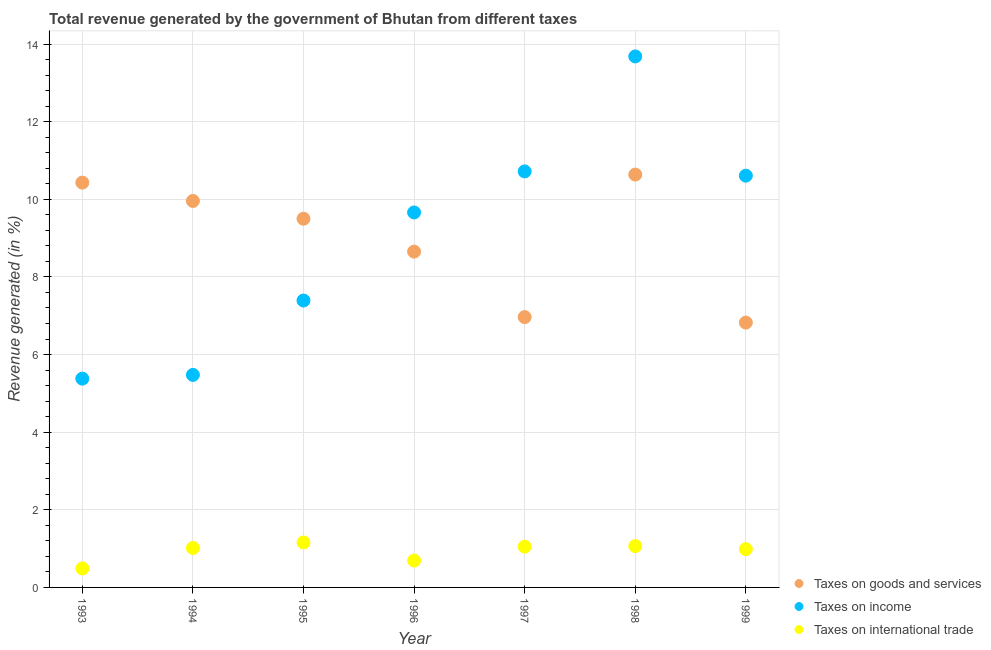What is the percentage of revenue generated by taxes on goods and services in 1999?
Your response must be concise. 6.82. Across all years, what is the maximum percentage of revenue generated by tax on international trade?
Your answer should be very brief. 1.16. Across all years, what is the minimum percentage of revenue generated by tax on international trade?
Offer a very short reply. 0.49. What is the total percentage of revenue generated by taxes on goods and services in the graph?
Provide a succinct answer. 62.97. What is the difference between the percentage of revenue generated by tax on international trade in 1996 and that in 1998?
Keep it short and to the point. -0.37. What is the difference between the percentage of revenue generated by taxes on income in 1998 and the percentage of revenue generated by taxes on goods and services in 1996?
Your answer should be compact. 5.03. What is the average percentage of revenue generated by taxes on income per year?
Your answer should be very brief. 8.99. In the year 1994, what is the difference between the percentage of revenue generated by tax on international trade and percentage of revenue generated by taxes on goods and services?
Offer a very short reply. -8.94. What is the ratio of the percentage of revenue generated by taxes on income in 1994 to that in 1996?
Your answer should be compact. 0.57. Is the percentage of revenue generated by taxes on goods and services in 1995 less than that in 1998?
Give a very brief answer. Yes. What is the difference between the highest and the second highest percentage of revenue generated by taxes on income?
Keep it short and to the point. 2.96. What is the difference between the highest and the lowest percentage of revenue generated by tax on international trade?
Ensure brevity in your answer.  0.67. In how many years, is the percentage of revenue generated by tax on international trade greater than the average percentage of revenue generated by tax on international trade taken over all years?
Make the answer very short. 5. Is the sum of the percentage of revenue generated by taxes on income in 1995 and 1998 greater than the maximum percentage of revenue generated by taxes on goods and services across all years?
Provide a succinct answer. Yes. Is it the case that in every year, the sum of the percentage of revenue generated by taxes on goods and services and percentage of revenue generated by taxes on income is greater than the percentage of revenue generated by tax on international trade?
Offer a very short reply. Yes. Does the percentage of revenue generated by tax on international trade monotonically increase over the years?
Give a very brief answer. No. Does the graph contain any zero values?
Make the answer very short. No. How many legend labels are there?
Offer a terse response. 3. What is the title of the graph?
Offer a very short reply. Total revenue generated by the government of Bhutan from different taxes. What is the label or title of the Y-axis?
Keep it short and to the point. Revenue generated (in %). What is the Revenue generated (in %) in Taxes on goods and services in 1993?
Offer a very short reply. 10.43. What is the Revenue generated (in %) of Taxes on income in 1993?
Give a very brief answer. 5.38. What is the Revenue generated (in %) of Taxes on international trade in 1993?
Provide a short and direct response. 0.49. What is the Revenue generated (in %) in Taxes on goods and services in 1994?
Make the answer very short. 9.96. What is the Revenue generated (in %) of Taxes on income in 1994?
Your answer should be compact. 5.48. What is the Revenue generated (in %) of Taxes on international trade in 1994?
Offer a terse response. 1.02. What is the Revenue generated (in %) in Taxes on goods and services in 1995?
Your answer should be compact. 9.5. What is the Revenue generated (in %) in Taxes on income in 1995?
Your answer should be compact. 7.39. What is the Revenue generated (in %) of Taxes on international trade in 1995?
Your answer should be very brief. 1.16. What is the Revenue generated (in %) of Taxes on goods and services in 1996?
Ensure brevity in your answer.  8.65. What is the Revenue generated (in %) in Taxes on income in 1996?
Provide a short and direct response. 9.66. What is the Revenue generated (in %) of Taxes on international trade in 1996?
Offer a very short reply. 0.69. What is the Revenue generated (in %) of Taxes on goods and services in 1997?
Provide a succinct answer. 6.97. What is the Revenue generated (in %) in Taxes on income in 1997?
Provide a short and direct response. 10.72. What is the Revenue generated (in %) of Taxes on international trade in 1997?
Ensure brevity in your answer.  1.05. What is the Revenue generated (in %) of Taxes on goods and services in 1998?
Provide a succinct answer. 10.64. What is the Revenue generated (in %) of Taxes on income in 1998?
Offer a very short reply. 13.68. What is the Revenue generated (in %) in Taxes on international trade in 1998?
Provide a succinct answer. 1.07. What is the Revenue generated (in %) in Taxes on goods and services in 1999?
Offer a very short reply. 6.82. What is the Revenue generated (in %) in Taxes on income in 1999?
Offer a very short reply. 10.61. What is the Revenue generated (in %) of Taxes on international trade in 1999?
Make the answer very short. 0.99. Across all years, what is the maximum Revenue generated (in %) in Taxes on goods and services?
Keep it short and to the point. 10.64. Across all years, what is the maximum Revenue generated (in %) in Taxes on income?
Provide a succinct answer. 13.68. Across all years, what is the maximum Revenue generated (in %) of Taxes on international trade?
Offer a terse response. 1.16. Across all years, what is the minimum Revenue generated (in %) of Taxes on goods and services?
Your answer should be compact. 6.82. Across all years, what is the minimum Revenue generated (in %) in Taxes on income?
Your answer should be compact. 5.38. Across all years, what is the minimum Revenue generated (in %) in Taxes on international trade?
Offer a terse response. 0.49. What is the total Revenue generated (in %) in Taxes on goods and services in the graph?
Your response must be concise. 62.97. What is the total Revenue generated (in %) in Taxes on income in the graph?
Your response must be concise. 62.92. What is the total Revenue generated (in %) of Taxes on international trade in the graph?
Your answer should be compact. 6.46. What is the difference between the Revenue generated (in %) in Taxes on goods and services in 1993 and that in 1994?
Provide a succinct answer. 0.47. What is the difference between the Revenue generated (in %) of Taxes on income in 1993 and that in 1994?
Offer a very short reply. -0.1. What is the difference between the Revenue generated (in %) of Taxes on international trade in 1993 and that in 1994?
Keep it short and to the point. -0.53. What is the difference between the Revenue generated (in %) of Taxes on goods and services in 1993 and that in 1995?
Give a very brief answer. 0.93. What is the difference between the Revenue generated (in %) of Taxes on income in 1993 and that in 1995?
Your answer should be very brief. -2.01. What is the difference between the Revenue generated (in %) of Taxes on international trade in 1993 and that in 1995?
Give a very brief answer. -0.67. What is the difference between the Revenue generated (in %) of Taxes on goods and services in 1993 and that in 1996?
Offer a very short reply. 1.78. What is the difference between the Revenue generated (in %) in Taxes on income in 1993 and that in 1996?
Your answer should be very brief. -4.28. What is the difference between the Revenue generated (in %) of Taxes on international trade in 1993 and that in 1996?
Give a very brief answer. -0.2. What is the difference between the Revenue generated (in %) of Taxes on goods and services in 1993 and that in 1997?
Give a very brief answer. 3.47. What is the difference between the Revenue generated (in %) in Taxes on income in 1993 and that in 1997?
Your response must be concise. -5.34. What is the difference between the Revenue generated (in %) in Taxes on international trade in 1993 and that in 1997?
Your response must be concise. -0.56. What is the difference between the Revenue generated (in %) in Taxes on goods and services in 1993 and that in 1998?
Your answer should be compact. -0.21. What is the difference between the Revenue generated (in %) in Taxes on income in 1993 and that in 1998?
Offer a very short reply. -8.3. What is the difference between the Revenue generated (in %) of Taxes on international trade in 1993 and that in 1998?
Offer a terse response. -0.58. What is the difference between the Revenue generated (in %) of Taxes on goods and services in 1993 and that in 1999?
Your answer should be very brief. 3.61. What is the difference between the Revenue generated (in %) of Taxes on income in 1993 and that in 1999?
Your answer should be very brief. -5.23. What is the difference between the Revenue generated (in %) of Taxes on international trade in 1993 and that in 1999?
Offer a very short reply. -0.5. What is the difference between the Revenue generated (in %) of Taxes on goods and services in 1994 and that in 1995?
Give a very brief answer. 0.46. What is the difference between the Revenue generated (in %) of Taxes on income in 1994 and that in 1995?
Your answer should be very brief. -1.92. What is the difference between the Revenue generated (in %) in Taxes on international trade in 1994 and that in 1995?
Offer a very short reply. -0.14. What is the difference between the Revenue generated (in %) in Taxes on goods and services in 1994 and that in 1996?
Provide a succinct answer. 1.31. What is the difference between the Revenue generated (in %) in Taxes on income in 1994 and that in 1996?
Offer a very short reply. -4.19. What is the difference between the Revenue generated (in %) of Taxes on international trade in 1994 and that in 1996?
Keep it short and to the point. 0.33. What is the difference between the Revenue generated (in %) in Taxes on goods and services in 1994 and that in 1997?
Keep it short and to the point. 2.99. What is the difference between the Revenue generated (in %) in Taxes on income in 1994 and that in 1997?
Provide a succinct answer. -5.24. What is the difference between the Revenue generated (in %) in Taxes on international trade in 1994 and that in 1997?
Your answer should be very brief. -0.03. What is the difference between the Revenue generated (in %) in Taxes on goods and services in 1994 and that in 1998?
Provide a succinct answer. -0.68. What is the difference between the Revenue generated (in %) in Taxes on income in 1994 and that in 1998?
Provide a short and direct response. -8.21. What is the difference between the Revenue generated (in %) in Taxes on international trade in 1994 and that in 1998?
Keep it short and to the point. -0.05. What is the difference between the Revenue generated (in %) in Taxes on goods and services in 1994 and that in 1999?
Your answer should be compact. 3.13. What is the difference between the Revenue generated (in %) in Taxes on income in 1994 and that in 1999?
Give a very brief answer. -5.13. What is the difference between the Revenue generated (in %) of Taxes on international trade in 1994 and that in 1999?
Your answer should be very brief. 0.03. What is the difference between the Revenue generated (in %) in Taxes on goods and services in 1995 and that in 1996?
Ensure brevity in your answer.  0.85. What is the difference between the Revenue generated (in %) in Taxes on income in 1995 and that in 1996?
Provide a succinct answer. -2.27. What is the difference between the Revenue generated (in %) in Taxes on international trade in 1995 and that in 1996?
Your response must be concise. 0.47. What is the difference between the Revenue generated (in %) in Taxes on goods and services in 1995 and that in 1997?
Ensure brevity in your answer.  2.53. What is the difference between the Revenue generated (in %) in Taxes on income in 1995 and that in 1997?
Give a very brief answer. -3.33. What is the difference between the Revenue generated (in %) in Taxes on international trade in 1995 and that in 1997?
Your answer should be compact. 0.11. What is the difference between the Revenue generated (in %) of Taxes on goods and services in 1995 and that in 1998?
Offer a very short reply. -1.14. What is the difference between the Revenue generated (in %) of Taxes on income in 1995 and that in 1998?
Your answer should be compact. -6.29. What is the difference between the Revenue generated (in %) in Taxes on international trade in 1995 and that in 1998?
Keep it short and to the point. 0.09. What is the difference between the Revenue generated (in %) of Taxes on goods and services in 1995 and that in 1999?
Your answer should be compact. 2.68. What is the difference between the Revenue generated (in %) in Taxes on income in 1995 and that in 1999?
Your answer should be compact. -3.22. What is the difference between the Revenue generated (in %) of Taxes on international trade in 1995 and that in 1999?
Provide a succinct answer. 0.17. What is the difference between the Revenue generated (in %) of Taxes on goods and services in 1996 and that in 1997?
Provide a short and direct response. 1.69. What is the difference between the Revenue generated (in %) in Taxes on income in 1996 and that in 1997?
Your answer should be very brief. -1.06. What is the difference between the Revenue generated (in %) in Taxes on international trade in 1996 and that in 1997?
Make the answer very short. -0.36. What is the difference between the Revenue generated (in %) of Taxes on goods and services in 1996 and that in 1998?
Offer a very short reply. -1.99. What is the difference between the Revenue generated (in %) of Taxes on income in 1996 and that in 1998?
Provide a short and direct response. -4.02. What is the difference between the Revenue generated (in %) in Taxes on international trade in 1996 and that in 1998?
Give a very brief answer. -0.37. What is the difference between the Revenue generated (in %) in Taxes on goods and services in 1996 and that in 1999?
Your answer should be very brief. 1.83. What is the difference between the Revenue generated (in %) in Taxes on income in 1996 and that in 1999?
Provide a succinct answer. -0.95. What is the difference between the Revenue generated (in %) in Taxes on international trade in 1996 and that in 1999?
Your answer should be very brief. -0.29. What is the difference between the Revenue generated (in %) in Taxes on goods and services in 1997 and that in 1998?
Offer a very short reply. -3.67. What is the difference between the Revenue generated (in %) in Taxes on income in 1997 and that in 1998?
Provide a short and direct response. -2.96. What is the difference between the Revenue generated (in %) of Taxes on international trade in 1997 and that in 1998?
Keep it short and to the point. -0.02. What is the difference between the Revenue generated (in %) in Taxes on goods and services in 1997 and that in 1999?
Provide a short and direct response. 0.14. What is the difference between the Revenue generated (in %) in Taxes on income in 1997 and that in 1999?
Make the answer very short. 0.11. What is the difference between the Revenue generated (in %) in Taxes on international trade in 1997 and that in 1999?
Offer a terse response. 0.06. What is the difference between the Revenue generated (in %) of Taxes on goods and services in 1998 and that in 1999?
Offer a terse response. 3.81. What is the difference between the Revenue generated (in %) of Taxes on income in 1998 and that in 1999?
Provide a short and direct response. 3.07. What is the difference between the Revenue generated (in %) in Taxes on international trade in 1998 and that in 1999?
Ensure brevity in your answer.  0.08. What is the difference between the Revenue generated (in %) of Taxes on goods and services in 1993 and the Revenue generated (in %) of Taxes on income in 1994?
Provide a short and direct response. 4.96. What is the difference between the Revenue generated (in %) in Taxes on goods and services in 1993 and the Revenue generated (in %) in Taxes on international trade in 1994?
Make the answer very short. 9.41. What is the difference between the Revenue generated (in %) of Taxes on income in 1993 and the Revenue generated (in %) of Taxes on international trade in 1994?
Provide a short and direct response. 4.36. What is the difference between the Revenue generated (in %) in Taxes on goods and services in 1993 and the Revenue generated (in %) in Taxes on income in 1995?
Ensure brevity in your answer.  3.04. What is the difference between the Revenue generated (in %) in Taxes on goods and services in 1993 and the Revenue generated (in %) in Taxes on international trade in 1995?
Give a very brief answer. 9.27. What is the difference between the Revenue generated (in %) of Taxes on income in 1993 and the Revenue generated (in %) of Taxes on international trade in 1995?
Your answer should be very brief. 4.22. What is the difference between the Revenue generated (in %) in Taxes on goods and services in 1993 and the Revenue generated (in %) in Taxes on income in 1996?
Ensure brevity in your answer.  0.77. What is the difference between the Revenue generated (in %) in Taxes on goods and services in 1993 and the Revenue generated (in %) in Taxes on international trade in 1996?
Your answer should be very brief. 9.74. What is the difference between the Revenue generated (in %) of Taxes on income in 1993 and the Revenue generated (in %) of Taxes on international trade in 1996?
Make the answer very short. 4.69. What is the difference between the Revenue generated (in %) of Taxes on goods and services in 1993 and the Revenue generated (in %) of Taxes on income in 1997?
Offer a terse response. -0.29. What is the difference between the Revenue generated (in %) in Taxes on goods and services in 1993 and the Revenue generated (in %) in Taxes on international trade in 1997?
Your response must be concise. 9.38. What is the difference between the Revenue generated (in %) of Taxes on income in 1993 and the Revenue generated (in %) of Taxes on international trade in 1997?
Your response must be concise. 4.33. What is the difference between the Revenue generated (in %) of Taxes on goods and services in 1993 and the Revenue generated (in %) of Taxes on income in 1998?
Ensure brevity in your answer.  -3.25. What is the difference between the Revenue generated (in %) in Taxes on goods and services in 1993 and the Revenue generated (in %) in Taxes on international trade in 1998?
Your answer should be compact. 9.37. What is the difference between the Revenue generated (in %) in Taxes on income in 1993 and the Revenue generated (in %) in Taxes on international trade in 1998?
Ensure brevity in your answer.  4.31. What is the difference between the Revenue generated (in %) in Taxes on goods and services in 1993 and the Revenue generated (in %) in Taxes on income in 1999?
Provide a short and direct response. -0.18. What is the difference between the Revenue generated (in %) of Taxes on goods and services in 1993 and the Revenue generated (in %) of Taxes on international trade in 1999?
Keep it short and to the point. 9.44. What is the difference between the Revenue generated (in %) of Taxes on income in 1993 and the Revenue generated (in %) of Taxes on international trade in 1999?
Your answer should be very brief. 4.39. What is the difference between the Revenue generated (in %) of Taxes on goods and services in 1994 and the Revenue generated (in %) of Taxes on income in 1995?
Ensure brevity in your answer.  2.57. What is the difference between the Revenue generated (in %) in Taxes on goods and services in 1994 and the Revenue generated (in %) in Taxes on international trade in 1995?
Offer a very short reply. 8.8. What is the difference between the Revenue generated (in %) in Taxes on income in 1994 and the Revenue generated (in %) in Taxes on international trade in 1995?
Ensure brevity in your answer.  4.32. What is the difference between the Revenue generated (in %) of Taxes on goods and services in 1994 and the Revenue generated (in %) of Taxes on income in 1996?
Provide a short and direct response. 0.3. What is the difference between the Revenue generated (in %) in Taxes on goods and services in 1994 and the Revenue generated (in %) in Taxes on international trade in 1996?
Offer a very short reply. 9.27. What is the difference between the Revenue generated (in %) in Taxes on income in 1994 and the Revenue generated (in %) in Taxes on international trade in 1996?
Offer a very short reply. 4.78. What is the difference between the Revenue generated (in %) of Taxes on goods and services in 1994 and the Revenue generated (in %) of Taxes on income in 1997?
Make the answer very short. -0.76. What is the difference between the Revenue generated (in %) of Taxes on goods and services in 1994 and the Revenue generated (in %) of Taxes on international trade in 1997?
Your answer should be very brief. 8.91. What is the difference between the Revenue generated (in %) in Taxes on income in 1994 and the Revenue generated (in %) in Taxes on international trade in 1997?
Offer a very short reply. 4.43. What is the difference between the Revenue generated (in %) of Taxes on goods and services in 1994 and the Revenue generated (in %) of Taxes on income in 1998?
Give a very brief answer. -3.72. What is the difference between the Revenue generated (in %) in Taxes on goods and services in 1994 and the Revenue generated (in %) in Taxes on international trade in 1998?
Offer a very short reply. 8.89. What is the difference between the Revenue generated (in %) of Taxes on income in 1994 and the Revenue generated (in %) of Taxes on international trade in 1998?
Offer a terse response. 4.41. What is the difference between the Revenue generated (in %) of Taxes on goods and services in 1994 and the Revenue generated (in %) of Taxes on income in 1999?
Your answer should be compact. -0.65. What is the difference between the Revenue generated (in %) in Taxes on goods and services in 1994 and the Revenue generated (in %) in Taxes on international trade in 1999?
Your answer should be compact. 8.97. What is the difference between the Revenue generated (in %) of Taxes on income in 1994 and the Revenue generated (in %) of Taxes on international trade in 1999?
Make the answer very short. 4.49. What is the difference between the Revenue generated (in %) of Taxes on goods and services in 1995 and the Revenue generated (in %) of Taxes on income in 1996?
Your response must be concise. -0.16. What is the difference between the Revenue generated (in %) of Taxes on goods and services in 1995 and the Revenue generated (in %) of Taxes on international trade in 1996?
Offer a terse response. 8.81. What is the difference between the Revenue generated (in %) in Taxes on income in 1995 and the Revenue generated (in %) in Taxes on international trade in 1996?
Offer a terse response. 6.7. What is the difference between the Revenue generated (in %) of Taxes on goods and services in 1995 and the Revenue generated (in %) of Taxes on income in 1997?
Your answer should be compact. -1.22. What is the difference between the Revenue generated (in %) in Taxes on goods and services in 1995 and the Revenue generated (in %) in Taxes on international trade in 1997?
Provide a short and direct response. 8.45. What is the difference between the Revenue generated (in %) in Taxes on income in 1995 and the Revenue generated (in %) in Taxes on international trade in 1997?
Your answer should be compact. 6.34. What is the difference between the Revenue generated (in %) of Taxes on goods and services in 1995 and the Revenue generated (in %) of Taxes on income in 1998?
Offer a very short reply. -4.18. What is the difference between the Revenue generated (in %) of Taxes on goods and services in 1995 and the Revenue generated (in %) of Taxes on international trade in 1998?
Your answer should be very brief. 8.43. What is the difference between the Revenue generated (in %) of Taxes on income in 1995 and the Revenue generated (in %) of Taxes on international trade in 1998?
Make the answer very short. 6.33. What is the difference between the Revenue generated (in %) in Taxes on goods and services in 1995 and the Revenue generated (in %) in Taxes on income in 1999?
Your response must be concise. -1.11. What is the difference between the Revenue generated (in %) in Taxes on goods and services in 1995 and the Revenue generated (in %) in Taxes on international trade in 1999?
Your response must be concise. 8.51. What is the difference between the Revenue generated (in %) in Taxes on income in 1995 and the Revenue generated (in %) in Taxes on international trade in 1999?
Provide a short and direct response. 6.41. What is the difference between the Revenue generated (in %) of Taxes on goods and services in 1996 and the Revenue generated (in %) of Taxes on income in 1997?
Your answer should be very brief. -2.07. What is the difference between the Revenue generated (in %) in Taxes on goods and services in 1996 and the Revenue generated (in %) in Taxes on international trade in 1997?
Offer a very short reply. 7.6. What is the difference between the Revenue generated (in %) of Taxes on income in 1996 and the Revenue generated (in %) of Taxes on international trade in 1997?
Provide a succinct answer. 8.61. What is the difference between the Revenue generated (in %) in Taxes on goods and services in 1996 and the Revenue generated (in %) in Taxes on income in 1998?
Give a very brief answer. -5.03. What is the difference between the Revenue generated (in %) in Taxes on goods and services in 1996 and the Revenue generated (in %) in Taxes on international trade in 1998?
Provide a succinct answer. 7.59. What is the difference between the Revenue generated (in %) in Taxes on income in 1996 and the Revenue generated (in %) in Taxes on international trade in 1998?
Your answer should be compact. 8.6. What is the difference between the Revenue generated (in %) in Taxes on goods and services in 1996 and the Revenue generated (in %) in Taxes on income in 1999?
Provide a short and direct response. -1.96. What is the difference between the Revenue generated (in %) in Taxes on goods and services in 1996 and the Revenue generated (in %) in Taxes on international trade in 1999?
Your response must be concise. 7.67. What is the difference between the Revenue generated (in %) of Taxes on income in 1996 and the Revenue generated (in %) of Taxes on international trade in 1999?
Offer a very short reply. 8.68. What is the difference between the Revenue generated (in %) of Taxes on goods and services in 1997 and the Revenue generated (in %) of Taxes on income in 1998?
Provide a short and direct response. -6.72. What is the difference between the Revenue generated (in %) in Taxes on goods and services in 1997 and the Revenue generated (in %) in Taxes on international trade in 1998?
Offer a terse response. 5.9. What is the difference between the Revenue generated (in %) in Taxes on income in 1997 and the Revenue generated (in %) in Taxes on international trade in 1998?
Ensure brevity in your answer.  9.65. What is the difference between the Revenue generated (in %) of Taxes on goods and services in 1997 and the Revenue generated (in %) of Taxes on income in 1999?
Give a very brief answer. -3.64. What is the difference between the Revenue generated (in %) of Taxes on goods and services in 1997 and the Revenue generated (in %) of Taxes on international trade in 1999?
Your response must be concise. 5.98. What is the difference between the Revenue generated (in %) in Taxes on income in 1997 and the Revenue generated (in %) in Taxes on international trade in 1999?
Your answer should be compact. 9.73. What is the difference between the Revenue generated (in %) in Taxes on goods and services in 1998 and the Revenue generated (in %) in Taxes on income in 1999?
Ensure brevity in your answer.  0.03. What is the difference between the Revenue generated (in %) of Taxes on goods and services in 1998 and the Revenue generated (in %) of Taxes on international trade in 1999?
Your answer should be very brief. 9.65. What is the difference between the Revenue generated (in %) in Taxes on income in 1998 and the Revenue generated (in %) in Taxes on international trade in 1999?
Your response must be concise. 12.7. What is the average Revenue generated (in %) in Taxes on goods and services per year?
Provide a succinct answer. 9. What is the average Revenue generated (in %) of Taxes on income per year?
Your response must be concise. 8.99. What is the average Revenue generated (in %) in Taxes on international trade per year?
Provide a short and direct response. 0.92. In the year 1993, what is the difference between the Revenue generated (in %) in Taxes on goods and services and Revenue generated (in %) in Taxes on income?
Provide a short and direct response. 5.05. In the year 1993, what is the difference between the Revenue generated (in %) of Taxes on goods and services and Revenue generated (in %) of Taxes on international trade?
Provide a short and direct response. 9.94. In the year 1993, what is the difference between the Revenue generated (in %) in Taxes on income and Revenue generated (in %) in Taxes on international trade?
Offer a terse response. 4.89. In the year 1994, what is the difference between the Revenue generated (in %) of Taxes on goods and services and Revenue generated (in %) of Taxes on income?
Provide a succinct answer. 4.48. In the year 1994, what is the difference between the Revenue generated (in %) of Taxes on goods and services and Revenue generated (in %) of Taxes on international trade?
Give a very brief answer. 8.94. In the year 1994, what is the difference between the Revenue generated (in %) in Taxes on income and Revenue generated (in %) in Taxes on international trade?
Your response must be concise. 4.46. In the year 1995, what is the difference between the Revenue generated (in %) in Taxes on goods and services and Revenue generated (in %) in Taxes on income?
Give a very brief answer. 2.11. In the year 1995, what is the difference between the Revenue generated (in %) of Taxes on goods and services and Revenue generated (in %) of Taxes on international trade?
Ensure brevity in your answer.  8.34. In the year 1995, what is the difference between the Revenue generated (in %) in Taxes on income and Revenue generated (in %) in Taxes on international trade?
Keep it short and to the point. 6.23. In the year 1996, what is the difference between the Revenue generated (in %) in Taxes on goods and services and Revenue generated (in %) in Taxes on income?
Your response must be concise. -1.01. In the year 1996, what is the difference between the Revenue generated (in %) of Taxes on goods and services and Revenue generated (in %) of Taxes on international trade?
Offer a very short reply. 7.96. In the year 1996, what is the difference between the Revenue generated (in %) in Taxes on income and Revenue generated (in %) in Taxes on international trade?
Provide a succinct answer. 8.97. In the year 1997, what is the difference between the Revenue generated (in %) of Taxes on goods and services and Revenue generated (in %) of Taxes on income?
Keep it short and to the point. -3.75. In the year 1997, what is the difference between the Revenue generated (in %) of Taxes on goods and services and Revenue generated (in %) of Taxes on international trade?
Keep it short and to the point. 5.92. In the year 1997, what is the difference between the Revenue generated (in %) of Taxes on income and Revenue generated (in %) of Taxes on international trade?
Your response must be concise. 9.67. In the year 1998, what is the difference between the Revenue generated (in %) of Taxes on goods and services and Revenue generated (in %) of Taxes on income?
Keep it short and to the point. -3.04. In the year 1998, what is the difference between the Revenue generated (in %) in Taxes on goods and services and Revenue generated (in %) in Taxes on international trade?
Make the answer very short. 9.57. In the year 1998, what is the difference between the Revenue generated (in %) in Taxes on income and Revenue generated (in %) in Taxes on international trade?
Give a very brief answer. 12.62. In the year 1999, what is the difference between the Revenue generated (in %) in Taxes on goods and services and Revenue generated (in %) in Taxes on income?
Your response must be concise. -3.79. In the year 1999, what is the difference between the Revenue generated (in %) of Taxes on goods and services and Revenue generated (in %) of Taxes on international trade?
Ensure brevity in your answer.  5.84. In the year 1999, what is the difference between the Revenue generated (in %) of Taxes on income and Revenue generated (in %) of Taxes on international trade?
Ensure brevity in your answer.  9.62. What is the ratio of the Revenue generated (in %) of Taxes on goods and services in 1993 to that in 1994?
Your answer should be very brief. 1.05. What is the ratio of the Revenue generated (in %) of Taxes on income in 1993 to that in 1994?
Your answer should be compact. 0.98. What is the ratio of the Revenue generated (in %) of Taxes on international trade in 1993 to that in 1994?
Give a very brief answer. 0.48. What is the ratio of the Revenue generated (in %) in Taxes on goods and services in 1993 to that in 1995?
Your answer should be compact. 1.1. What is the ratio of the Revenue generated (in %) in Taxes on income in 1993 to that in 1995?
Give a very brief answer. 0.73. What is the ratio of the Revenue generated (in %) in Taxes on international trade in 1993 to that in 1995?
Provide a short and direct response. 0.42. What is the ratio of the Revenue generated (in %) in Taxes on goods and services in 1993 to that in 1996?
Provide a short and direct response. 1.21. What is the ratio of the Revenue generated (in %) in Taxes on income in 1993 to that in 1996?
Your response must be concise. 0.56. What is the ratio of the Revenue generated (in %) of Taxes on international trade in 1993 to that in 1996?
Offer a very short reply. 0.71. What is the ratio of the Revenue generated (in %) of Taxes on goods and services in 1993 to that in 1997?
Give a very brief answer. 1.5. What is the ratio of the Revenue generated (in %) of Taxes on income in 1993 to that in 1997?
Your answer should be very brief. 0.5. What is the ratio of the Revenue generated (in %) in Taxes on international trade in 1993 to that in 1997?
Make the answer very short. 0.47. What is the ratio of the Revenue generated (in %) in Taxes on goods and services in 1993 to that in 1998?
Your answer should be very brief. 0.98. What is the ratio of the Revenue generated (in %) of Taxes on income in 1993 to that in 1998?
Your answer should be very brief. 0.39. What is the ratio of the Revenue generated (in %) in Taxes on international trade in 1993 to that in 1998?
Offer a terse response. 0.46. What is the ratio of the Revenue generated (in %) in Taxes on goods and services in 1993 to that in 1999?
Your answer should be very brief. 1.53. What is the ratio of the Revenue generated (in %) in Taxes on income in 1993 to that in 1999?
Your answer should be compact. 0.51. What is the ratio of the Revenue generated (in %) of Taxes on international trade in 1993 to that in 1999?
Provide a succinct answer. 0.5. What is the ratio of the Revenue generated (in %) in Taxes on goods and services in 1994 to that in 1995?
Offer a very short reply. 1.05. What is the ratio of the Revenue generated (in %) of Taxes on income in 1994 to that in 1995?
Ensure brevity in your answer.  0.74. What is the ratio of the Revenue generated (in %) of Taxes on international trade in 1994 to that in 1995?
Ensure brevity in your answer.  0.88. What is the ratio of the Revenue generated (in %) in Taxes on goods and services in 1994 to that in 1996?
Offer a terse response. 1.15. What is the ratio of the Revenue generated (in %) of Taxes on income in 1994 to that in 1996?
Make the answer very short. 0.57. What is the ratio of the Revenue generated (in %) in Taxes on international trade in 1994 to that in 1996?
Your answer should be compact. 1.47. What is the ratio of the Revenue generated (in %) of Taxes on goods and services in 1994 to that in 1997?
Make the answer very short. 1.43. What is the ratio of the Revenue generated (in %) in Taxes on income in 1994 to that in 1997?
Your answer should be compact. 0.51. What is the ratio of the Revenue generated (in %) in Taxes on international trade in 1994 to that in 1997?
Give a very brief answer. 0.97. What is the ratio of the Revenue generated (in %) in Taxes on goods and services in 1994 to that in 1998?
Your answer should be very brief. 0.94. What is the ratio of the Revenue generated (in %) of Taxes on income in 1994 to that in 1998?
Your answer should be very brief. 0.4. What is the ratio of the Revenue generated (in %) in Taxes on international trade in 1994 to that in 1998?
Your answer should be very brief. 0.95. What is the ratio of the Revenue generated (in %) in Taxes on goods and services in 1994 to that in 1999?
Make the answer very short. 1.46. What is the ratio of the Revenue generated (in %) in Taxes on income in 1994 to that in 1999?
Provide a succinct answer. 0.52. What is the ratio of the Revenue generated (in %) in Taxes on international trade in 1994 to that in 1999?
Your answer should be compact. 1.03. What is the ratio of the Revenue generated (in %) in Taxes on goods and services in 1995 to that in 1996?
Offer a very short reply. 1.1. What is the ratio of the Revenue generated (in %) of Taxes on income in 1995 to that in 1996?
Keep it short and to the point. 0.77. What is the ratio of the Revenue generated (in %) in Taxes on international trade in 1995 to that in 1996?
Offer a very short reply. 1.68. What is the ratio of the Revenue generated (in %) in Taxes on goods and services in 1995 to that in 1997?
Offer a very short reply. 1.36. What is the ratio of the Revenue generated (in %) in Taxes on income in 1995 to that in 1997?
Your answer should be compact. 0.69. What is the ratio of the Revenue generated (in %) of Taxes on international trade in 1995 to that in 1997?
Provide a succinct answer. 1.1. What is the ratio of the Revenue generated (in %) in Taxes on goods and services in 1995 to that in 1998?
Ensure brevity in your answer.  0.89. What is the ratio of the Revenue generated (in %) of Taxes on income in 1995 to that in 1998?
Keep it short and to the point. 0.54. What is the ratio of the Revenue generated (in %) of Taxes on international trade in 1995 to that in 1998?
Offer a terse response. 1.09. What is the ratio of the Revenue generated (in %) in Taxes on goods and services in 1995 to that in 1999?
Offer a terse response. 1.39. What is the ratio of the Revenue generated (in %) in Taxes on income in 1995 to that in 1999?
Provide a short and direct response. 0.7. What is the ratio of the Revenue generated (in %) of Taxes on international trade in 1995 to that in 1999?
Your answer should be very brief. 1.17. What is the ratio of the Revenue generated (in %) in Taxes on goods and services in 1996 to that in 1997?
Offer a terse response. 1.24. What is the ratio of the Revenue generated (in %) of Taxes on income in 1996 to that in 1997?
Your answer should be compact. 0.9. What is the ratio of the Revenue generated (in %) of Taxes on international trade in 1996 to that in 1997?
Your answer should be compact. 0.66. What is the ratio of the Revenue generated (in %) of Taxes on goods and services in 1996 to that in 1998?
Provide a succinct answer. 0.81. What is the ratio of the Revenue generated (in %) in Taxes on income in 1996 to that in 1998?
Provide a succinct answer. 0.71. What is the ratio of the Revenue generated (in %) of Taxes on international trade in 1996 to that in 1998?
Make the answer very short. 0.65. What is the ratio of the Revenue generated (in %) in Taxes on goods and services in 1996 to that in 1999?
Your answer should be compact. 1.27. What is the ratio of the Revenue generated (in %) of Taxes on income in 1996 to that in 1999?
Offer a terse response. 0.91. What is the ratio of the Revenue generated (in %) in Taxes on international trade in 1996 to that in 1999?
Give a very brief answer. 0.7. What is the ratio of the Revenue generated (in %) in Taxes on goods and services in 1997 to that in 1998?
Your answer should be compact. 0.65. What is the ratio of the Revenue generated (in %) in Taxes on income in 1997 to that in 1998?
Your answer should be very brief. 0.78. What is the ratio of the Revenue generated (in %) of Taxes on international trade in 1997 to that in 1998?
Provide a short and direct response. 0.99. What is the ratio of the Revenue generated (in %) of Taxes on goods and services in 1997 to that in 1999?
Keep it short and to the point. 1.02. What is the ratio of the Revenue generated (in %) in Taxes on income in 1997 to that in 1999?
Your answer should be very brief. 1.01. What is the ratio of the Revenue generated (in %) of Taxes on international trade in 1997 to that in 1999?
Provide a short and direct response. 1.06. What is the ratio of the Revenue generated (in %) of Taxes on goods and services in 1998 to that in 1999?
Offer a terse response. 1.56. What is the ratio of the Revenue generated (in %) of Taxes on income in 1998 to that in 1999?
Offer a very short reply. 1.29. What is the difference between the highest and the second highest Revenue generated (in %) in Taxes on goods and services?
Provide a short and direct response. 0.21. What is the difference between the highest and the second highest Revenue generated (in %) of Taxes on income?
Your answer should be compact. 2.96. What is the difference between the highest and the second highest Revenue generated (in %) of Taxes on international trade?
Give a very brief answer. 0.09. What is the difference between the highest and the lowest Revenue generated (in %) of Taxes on goods and services?
Make the answer very short. 3.81. What is the difference between the highest and the lowest Revenue generated (in %) of Taxes on income?
Make the answer very short. 8.3. What is the difference between the highest and the lowest Revenue generated (in %) of Taxes on international trade?
Keep it short and to the point. 0.67. 